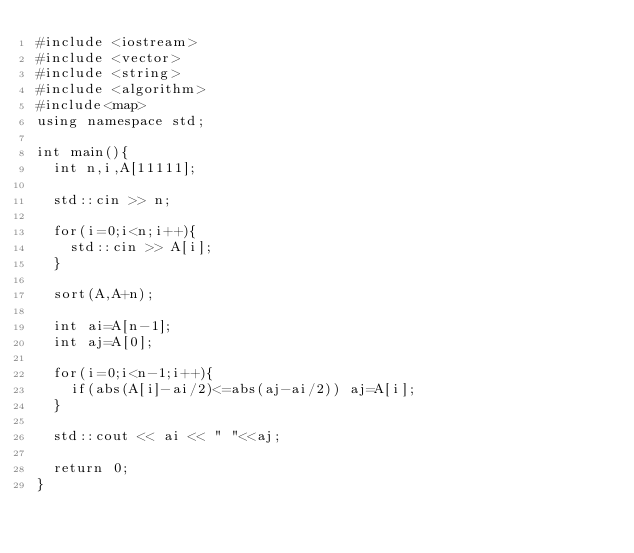Convert code to text. <code><loc_0><loc_0><loc_500><loc_500><_C++_>#include <iostream>
#include <vector>
#include <string>
#include <algorithm>
#include<map>
using namespace std;

int main(){
  int n,i,A[11111];

  std::cin >> n;

  for(i=0;i<n;i++){
    std::cin >> A[i];
  }

  sort(A,A+n);

  int ai=A[n-1];
  int aj=A[0];

  for(i=0;i<n-1;i++){
    if(abs(A[i]-ai/2)<=abs(aj-ai/2)) aj=A[i];
  }

  std::cout << ai << " "<<aj;

  return 0;
}
</code> 